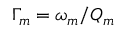<formula> <loc_0><loc_0><loc_500><loc_500>\Gamma _ { m } = \omega _ { m } / Q _ { m }</formula> 